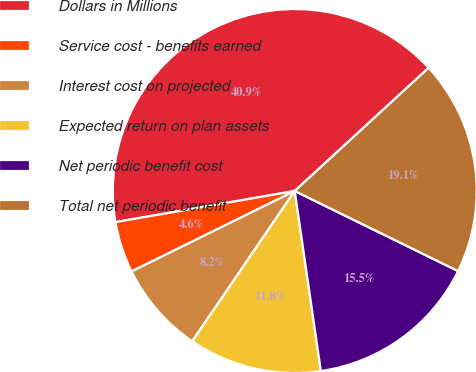<chart> <loc_0><loc_0><loc_500><loc_500><pie_chart><fcel>Dollars in Millions<fcel>Service cost - benefits earned<fcel>Interest cost on projected<fcel>Expected return on plan assets<fcel>Net periodic benefit cost<fcel>Total net periodic benefit<nl><fcel>40.9%<fcel>4.55%<fcel>8.18%<fcel>11.82%<fcel>15.45%<fcel>19.09%<nl></chart> 